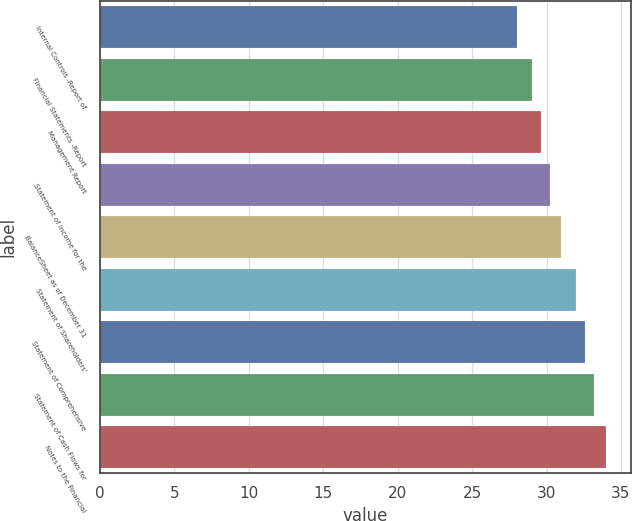<chart> <loc_0><loc_0><loc_500><loc_500><bar_chart><fcel>Internal Controls -Report of<fcel>Financial Statements -Report<fcel>Management Report<fcel>Statement of Income for the<fcel>BalanceSheet as of December 31<fcel>Statement of Shareholders'<fcel>Statement of Comprehensive<fcel>Statement of Cash Flows for<fcel>Notes to the Financial<nl><fcel>28<fcel>29<fcel>29.6<fcel>30.2<fcel>31<fcel>32<fcel>32.6<fcel>33.2<fcel>34<nl></chart> 